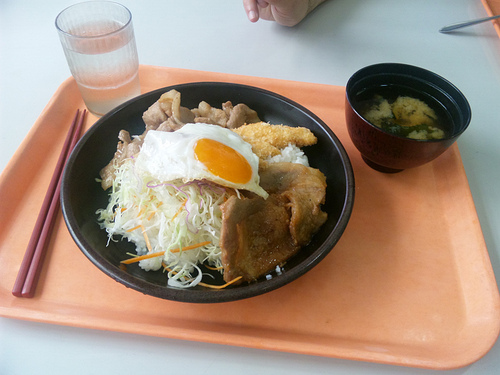<image>
Can you confirm if the plank is under the pirate? No. The plank is not positioned under the pirate. The vertical relationship between these objects is different. 